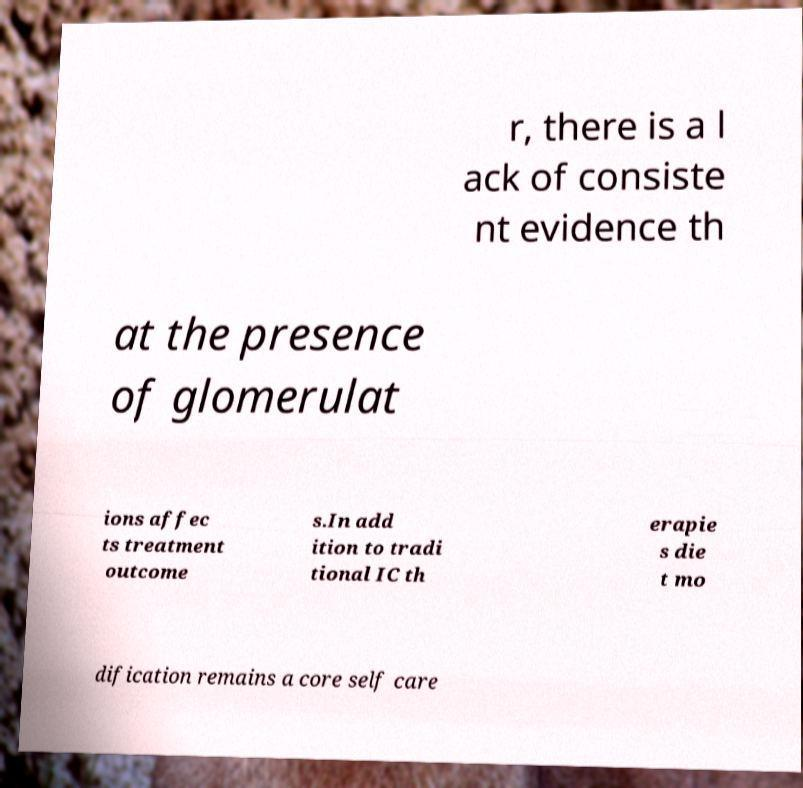Could you assist in decoding the text presented in this image and type it out clearly? r, there is a l ack of consiste nt evidence th at the presence of glomerulat ions affec ts treatment outcome s.In add ition to tradi tional IC th erapie s die t mo dification remains a core self care 